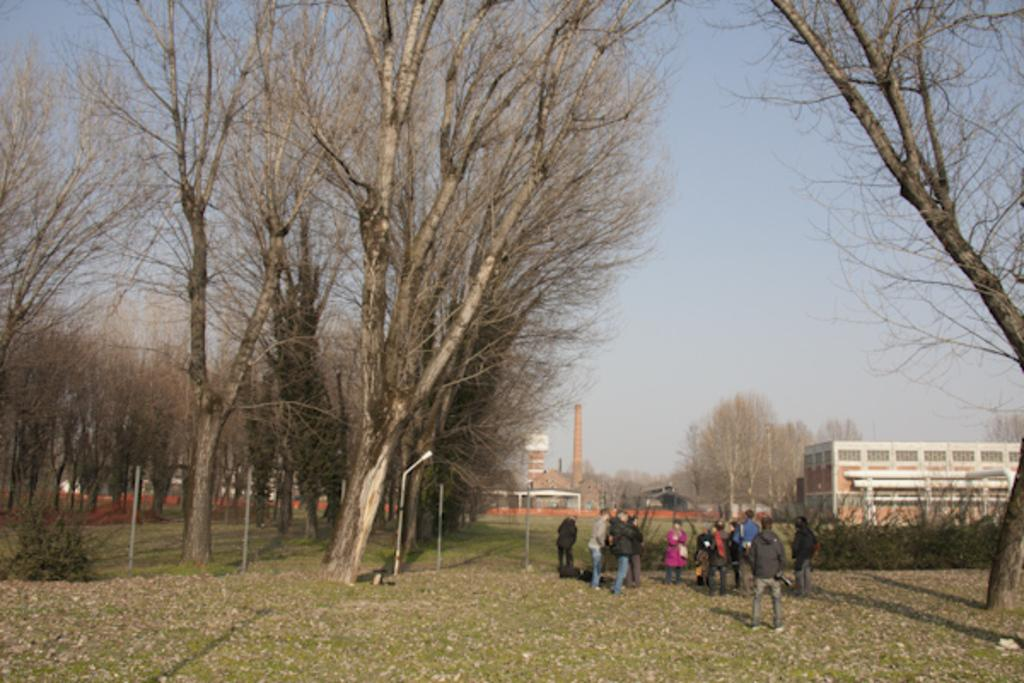Who or what can be seen in the image? There are people in the image. What can be seen in the distance behind the people? There are trees, buildings, and a tower in the background of the image. What is the area in the image surrounded by? There is a boundary around the area in the image. What is on the ground in the image? There are dried leaves on the ground in the image. Where is the hydrant located in the image? There is no hydrant present in the image. What type of joke can be seen being told by the people in the image? There is no joke being told by the people in the image; they are not engaged in any such activity. 